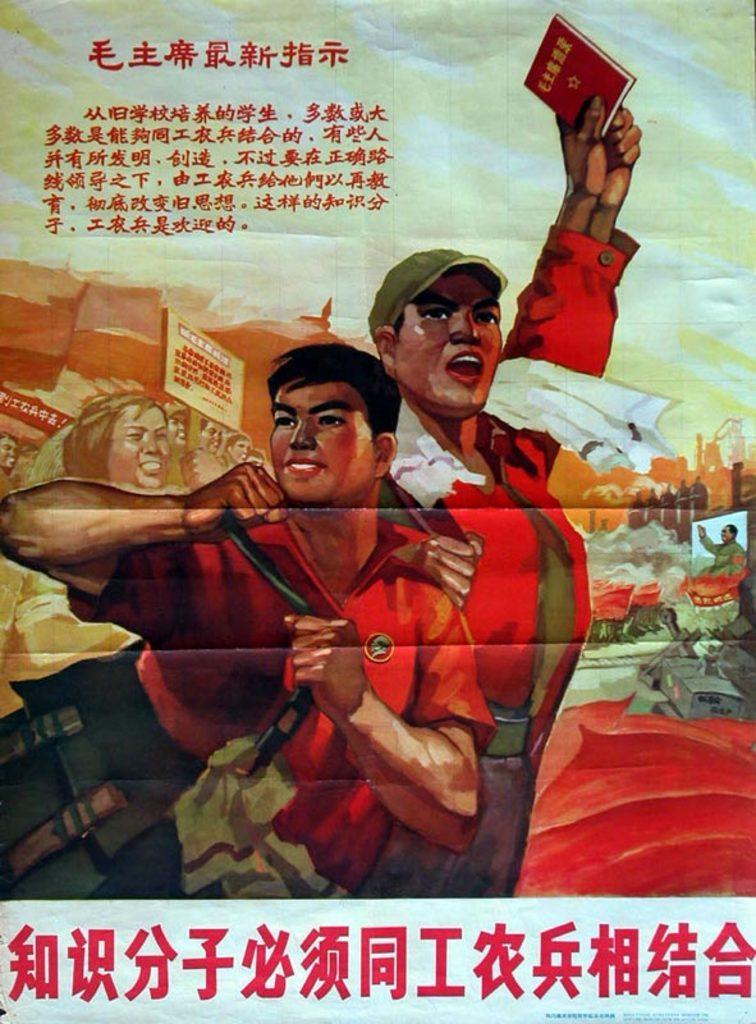In one or two sentences, can you explain what this image depicts? In this image we can see a poster of some persons most of them are wearing red color dress and some are holding books in their hands and there is some text which is in different language. 